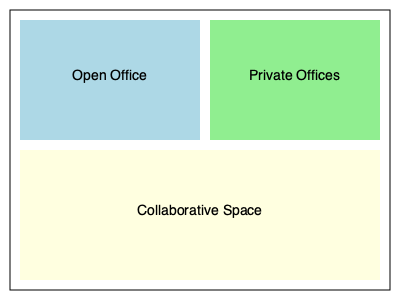Based on the office layout floor plan provided, which area is likely to have the highest impact on productivity for tasks requiring focused individual work, and why might this layout potentially hinder overall office productivity? To answer this question, we need to analyze the different areas of the office layout and their potential impact on productivity:

1. Open Office Area:
   - Pros: Encourages communication and collaboration
   - Cons: Can be noisy and distracting for focused work

2. Private Offices:
   - Pros: Provides quiet space for concentrated work
   - Cons: May reduce spontaneous interactions and team cohesion

3. Collaborative Space:
   - Pros: Facilitates teamwork and brainstorming sessions
   - Cons: Not suitable for tasks requiring individual focus

For tasks requiring focused individual work, the private offices are likely to have the highest impact on productivity. This is because they provide a quiet, distraction-free environment that allows employees to concentrate on complex tasks.

However, this layout might potentially hinder overall office productivity for the following reasons:

1. Limited private office space: Only a small portion of the office is dedicated to private offices, which may create competition for these spaces.

2. Potential for isolation: The separation between open and private areas might lead to reduced communication and collaboration between teams.

3. Inefficient use of space: The large collaborative area might be underutilized if not properly managed, taking away space that could be used for more productive purposes.

4. Lack of flexibility: The fixed layout doesn't allow for easy reconfiguration to accommodate changing team sizes or project needs.

5. Potential for increased stress: Employees in the open office area might experience higher stress levels due to noise and distractions, which can negatively impact overall productivity.

To optimize productivity, a more balanced approach with a mix of open and private spaces, along with flexible areas that can be adapted for different work styles, might be more effective.
Answer: Private offices; layout lacks balance and flexibility 